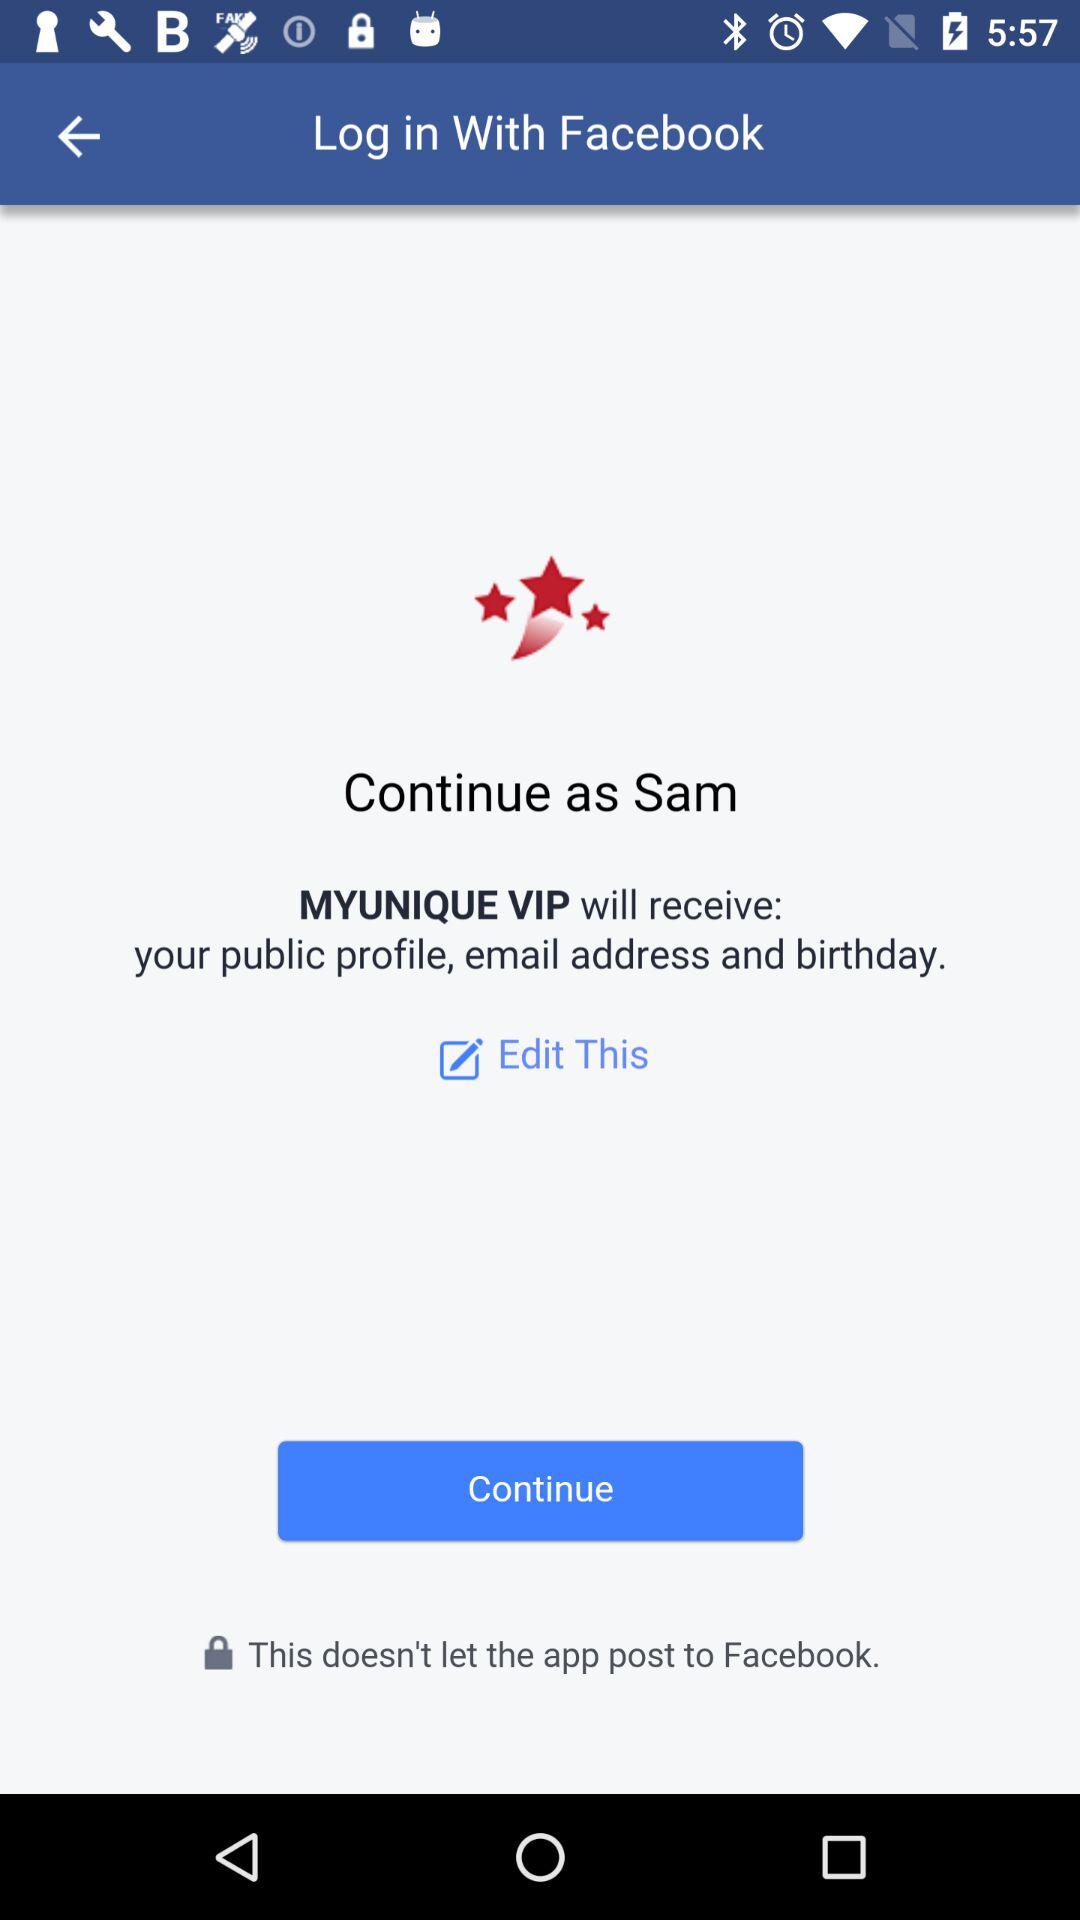What application is asking for permission? The application asking for permission is "MYUNIQUE VIP". 